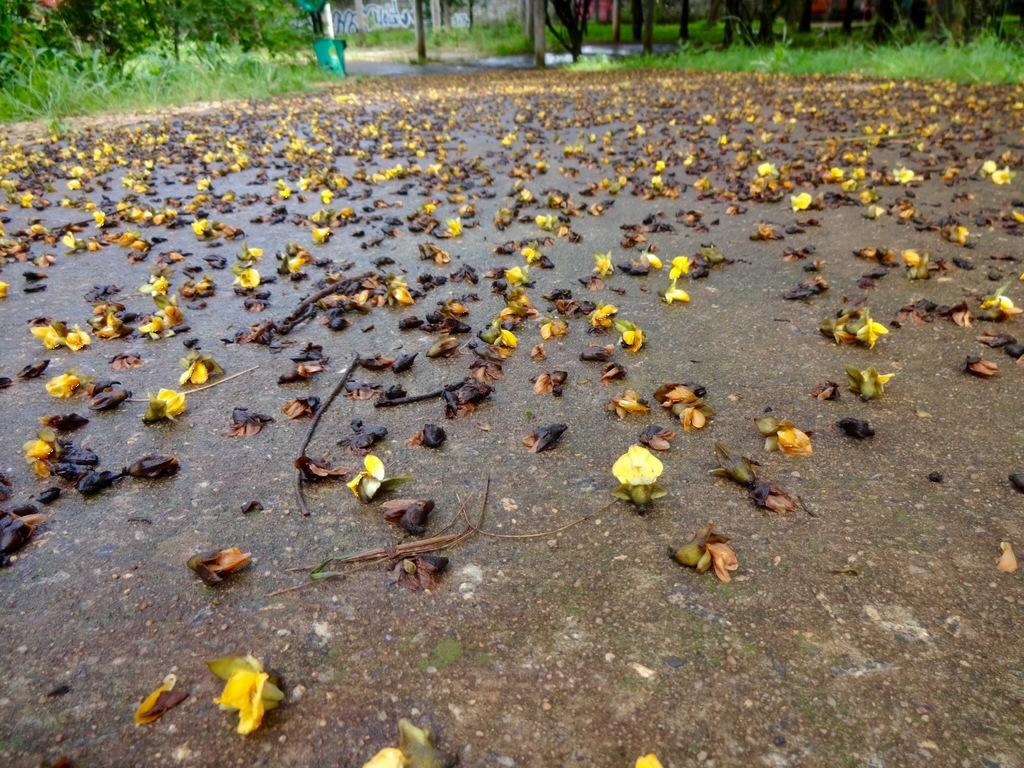What is present on the road at the bottom of the image? There are flowers on the road at the bottom of the image. What type of vegetation can be seen in the background of the image? There is grass in the background of the image. What else can be seen in the background of the image? There are tree trunks in the background of the image. Can you describe the wave pattern on the road in the image? There is no wave pattern present on the road in the image; it features flowers instead. How much snow can be seen on the tree trunks in the image? There is no snow present on the tree trunks in the image; it is not mentioned in the provided facts. 